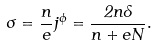Convert formula to latex. <formula><loc_0><loc_0><loc_500><loc_500>\sigma = \frac { n } { e } j ^ { \phi } = \frac { 2 n \Lambda } { n + e N } .</formula> 